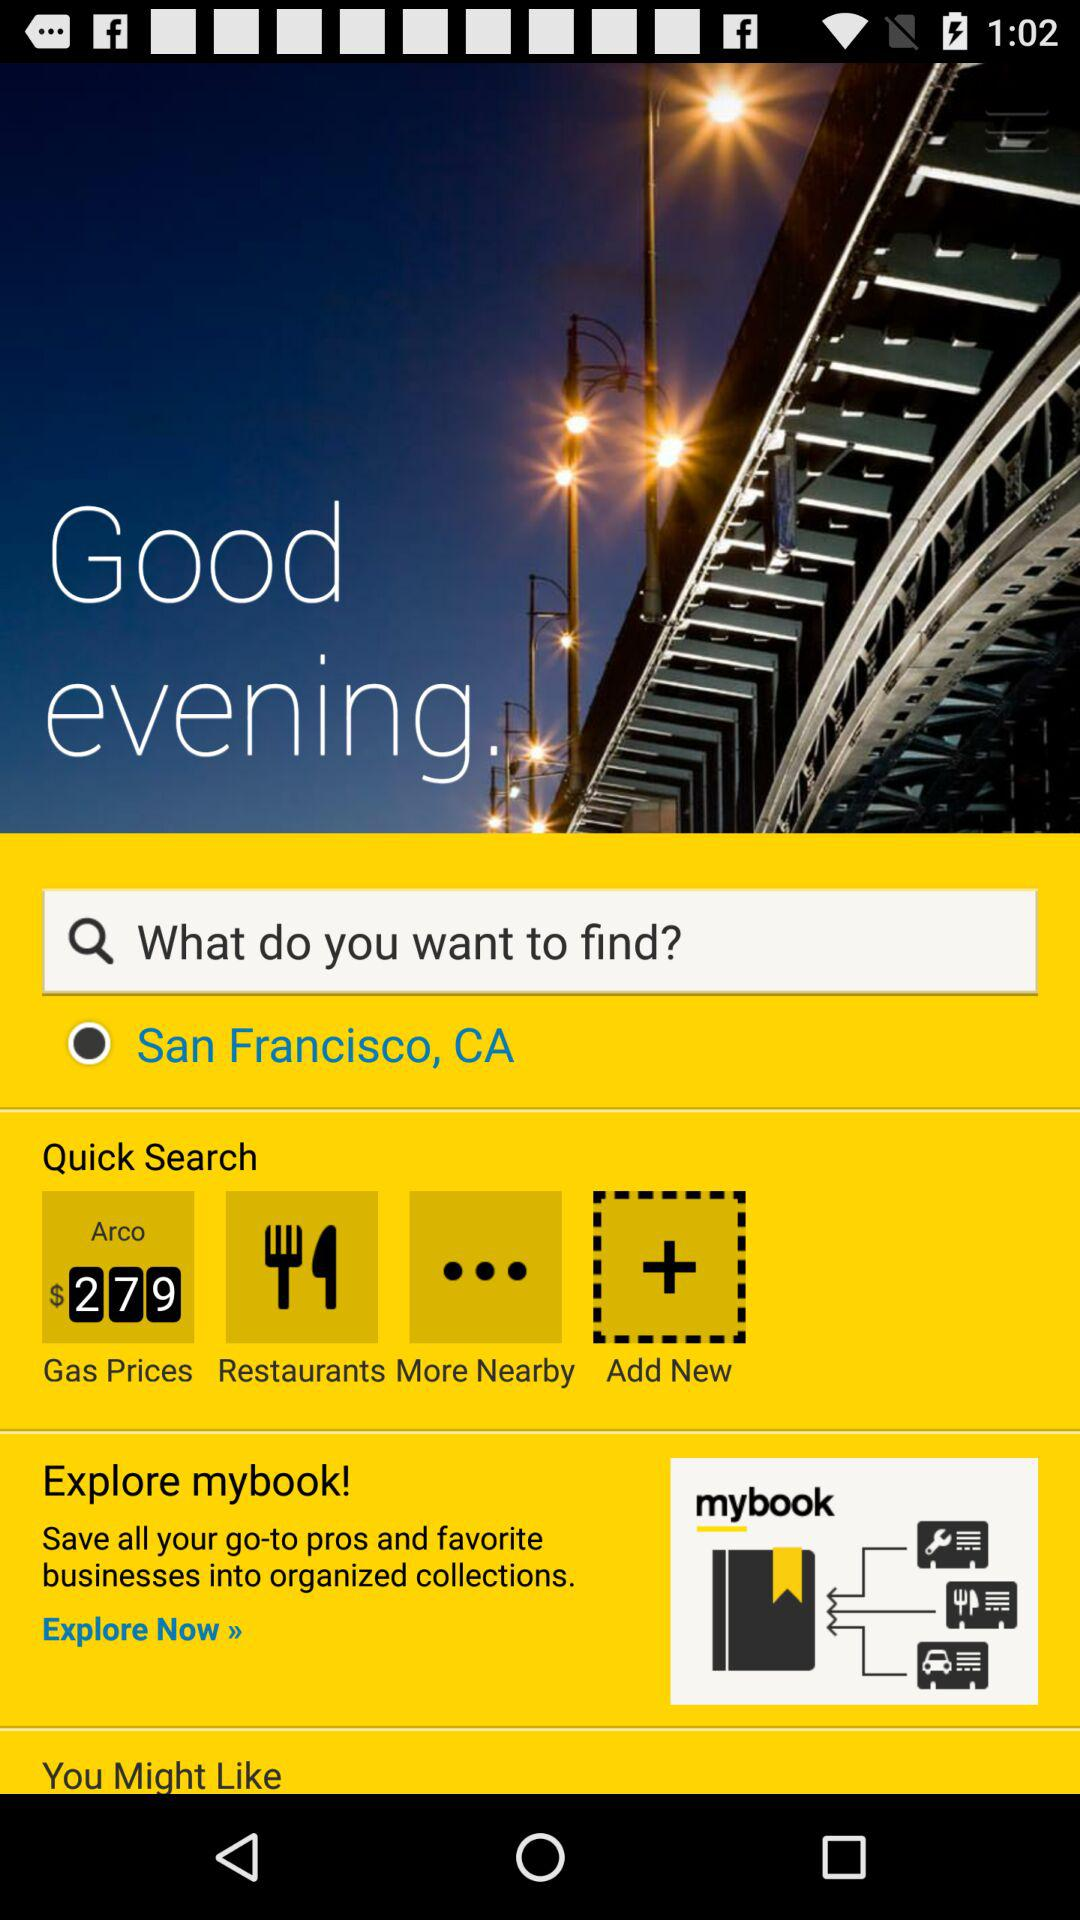Which place has been selected? The selected place is San Francisco, CA. 